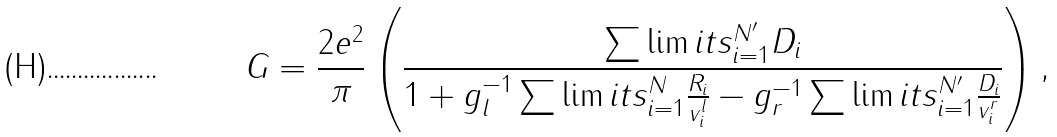<formula> <loc_0><loc_0><loc_500><loc_500>G = \frac { 2 e ^ { 2 } } { \pi } \left ( \frac { \sum \lim i t s _ { i = 1 } ^ { N ^ { \prime } } D _ { i } } { 1 + g _ { l } ^ { - 1 } \sum \lim i t s _ { i = 1 } ^ { N } \frac { R _ { i } } { v _ { i } ^ { l } } - g _ { r } ^ { - 1 } \sum \lim i t s _ { i = 1 } ^ { N ^ { \prime } } \frac { D _ { i } } { v _ { i } ^ { r } } } \right ) ,</formula> 